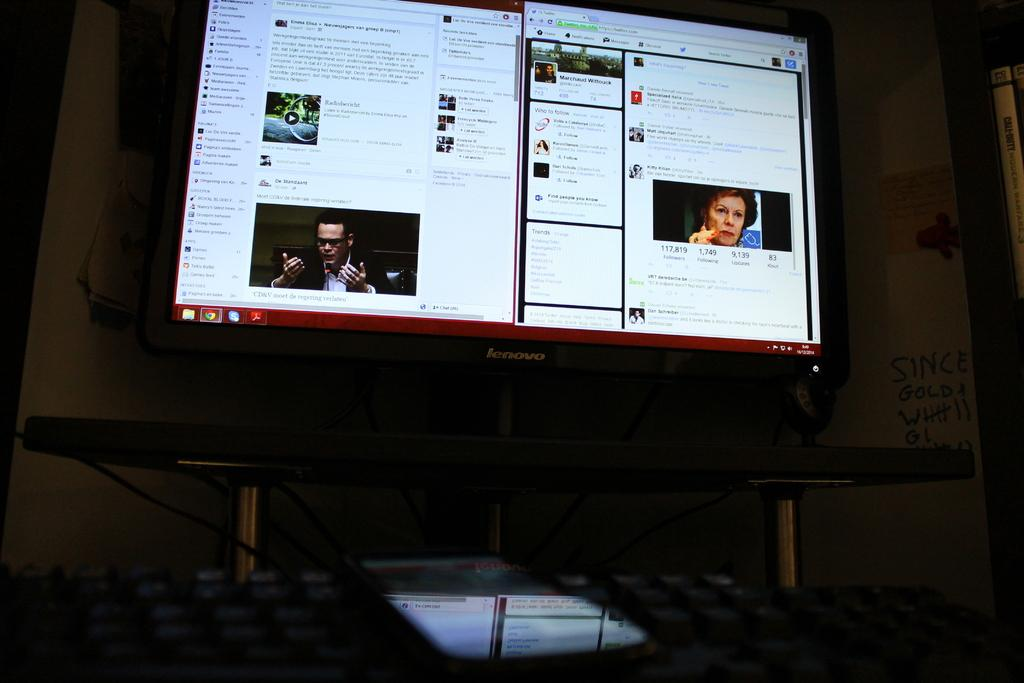<image>
Render a clear and concise summary of the photo. Lenovo computer monitor on a website for Marchaud Wittouck. 